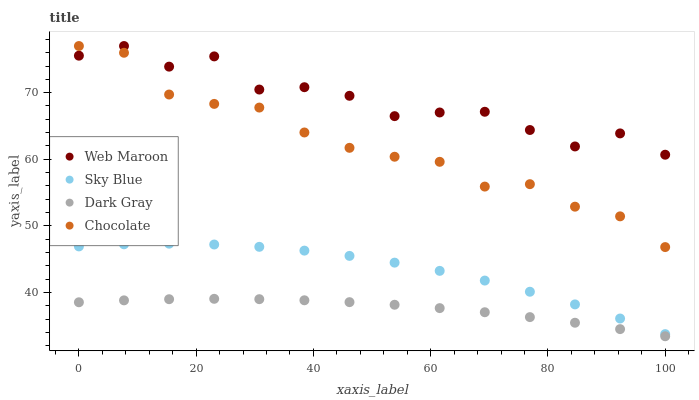Does Dark Gray have the minimum area under the curve?
Answer yes or no. Yes. Does Web Maroon have the maximum area under the curve?
Answer yes or no. Yes. Does Sky Blue have the minimum area under the curve?
Answer yes or no. No. Does Sky Blue have the maximum area under the curve?
Answer yes or no. No. Is Dark Gray the smoothest?
Answer yes or no. Yes. Is Web Maroon the roughest?
Answer yes or no. Yes. Is Sky Blue the smoothest?
Answer yes or no. No. Is Sky Blue the roughest?
Answer yes or no. No. Does Dark Gray have the lowest value?
Answer yes or no. Yes. Does Sky Blue have the lowest value?
Answer yes or no. No. Does Chocolate have the highest value?
Answer yes or no. Yes. Does Sky Blue have the highest value?
Answer yes or no. No. Is Sky Blue less than Web Maroon?
Answer yes or no. Yes. Is Web Maroon greater than Sky Blue?
Answer yes or no. Yes. Does Chocolate intersect Web Maroon?
Answer yes or no. Yes. Is Chocolate less than Web Maroon?
Answer yes or no. No. Is Chocolate greater than Web Maroon?
Answer yes or no. No. Does Sky Blue intersect Web Maroon?
Answer yes or no. No. 